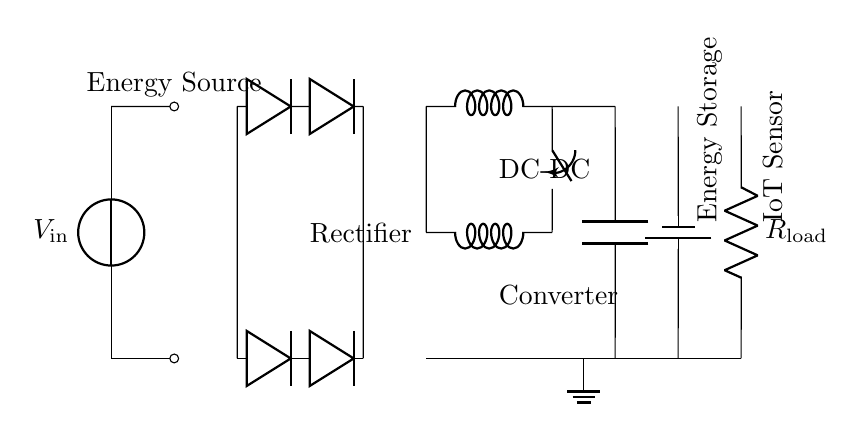What is the energy source in the circuit? The energy source is labeled as \( V_\text{in} \), indicating its role in supplying power to the rest of the circuit.
Answer: \( V_\text{in} \) What type of circuit does the diagram represent? The diagram represents an energy harvesting circuit designed for self-powered IoT sensors in smart factories, focusing on energy conversion and storage.
Answer: Energy harvesting circuit How many diodes are used in the rectifier section? There are four diodes shown in the rectifier section of the circuit, arranged to create a full-wave rectifier configuration.
Answer: Four What is connected to the output of the DC-DC converter? The load connected to the output of the DC-DC converter is labeled as \( R_\text{load} \), which represents the IoT sensor operated by the harvested energy.
Answer: \( R_\text{load} \) Explain the purpose of the battery in this circuit. The battery acts as the energy storage component, allowing it to store the harvested energy for later use by the IoT sensor, which may not require constant energy availability from the source.
Answer: Energy storage What is the configuration of the rectifier in the circuit? The rectifier is set up in a full-wave configuration, utilizing two sets of diodes arranged to allow current flow during both halves of the input AC cycle.
Answer: Full-wave rectifier Which component primarily regulates the voltage output for the IoT sensor? The DC-DC converter is the component that primarily regulates the voltage output, ensuring that the voltage delivered to the IoT sensor is stable and appropriate for its operation.
Answer: DC-DC Converter 